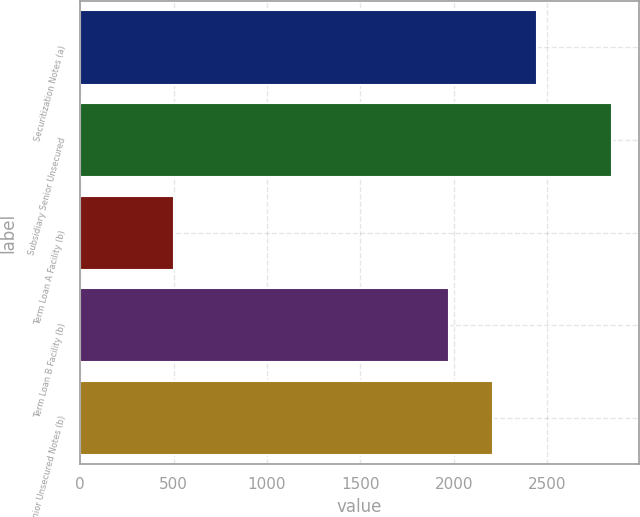<chart> <loc_0><loc_0><loc_500><loc_500><bar_chart><fcel>Securitization Notes (a)<fcel>Subsidiary Senior Unsecured<fcel>Term Loan A Facility (b)<fcel>Term Loan B Facility (b)<fcel>YUM Senior Unsecured Notes (b)<nl><fcel>2445<fcel>2850<fcel>500<fcel>1975<fcel>2210<nl></chart> 